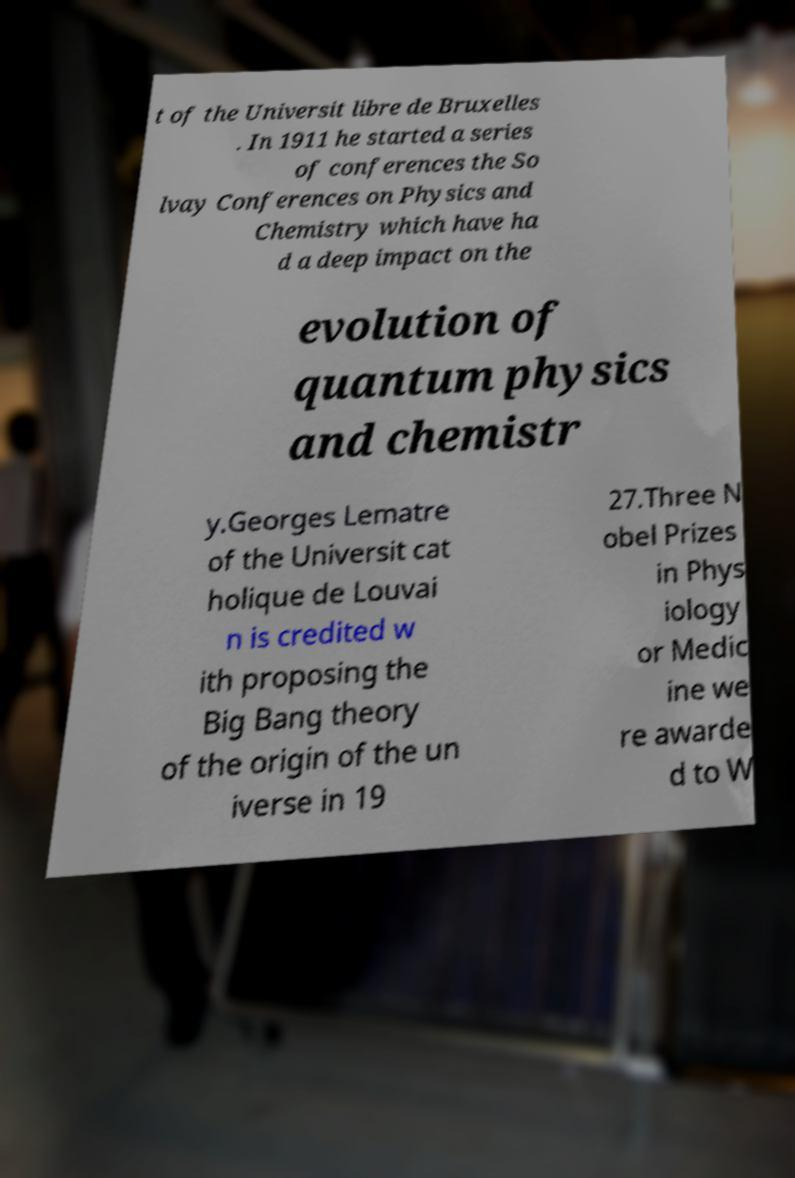For documentation purposes, I need the text within this image transcribed. Could you provide that? t of the Universit libre de Bruxelles . In 1911 he started a series of conferences the So lvay Conferences on Physics and Chemistry which have ha d a deep impact on the evolution of quantum physics and chemistr y.Georges Lematre of the Universit cat holique de Louvai n is credited w ith proposing the Big Bang theory of the origin of the un iverse in 19 27.Three N obel Prizes in Phys iology or Medic ine we re awarde d to W 